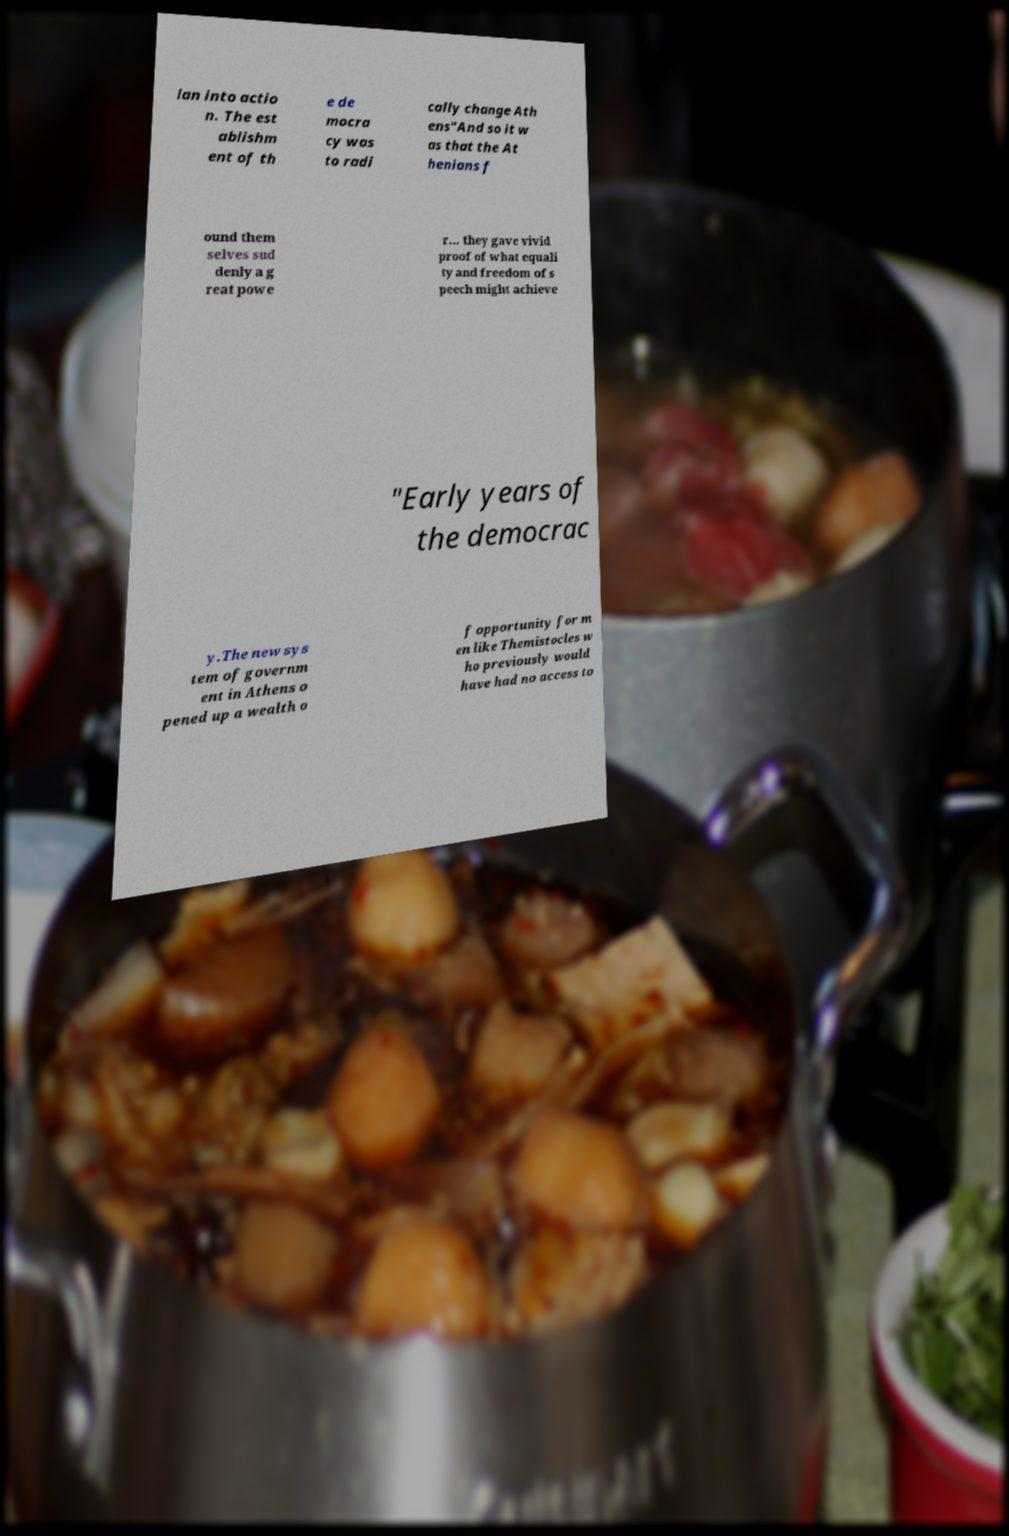I need the written content from this picture converted into text. Can you do that? lan into actio n. The est ablishm ent of th e de mocra cy was to radi cally change Ath ens"And so it w as that the At henians f ound them selves sud denly a g reat powe r... they gave vivid proof of what equali ty and freedom of s peech might achieve "Early years of the democrac y.The new sys tem of governm ent in Athens o pened up a wealth o f opportunity for m en like Themistocles w ho previously would have had no access to 